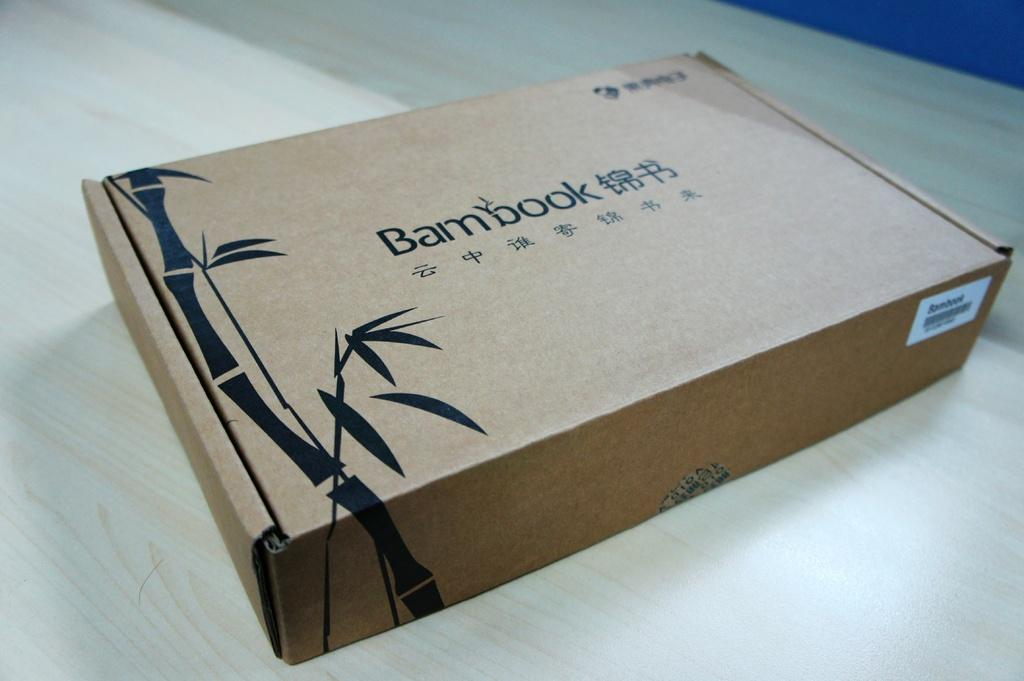<image>
Relay a brief, clear account of the picture shown. A box, labelled Bambook, is resting on a wooden table. 